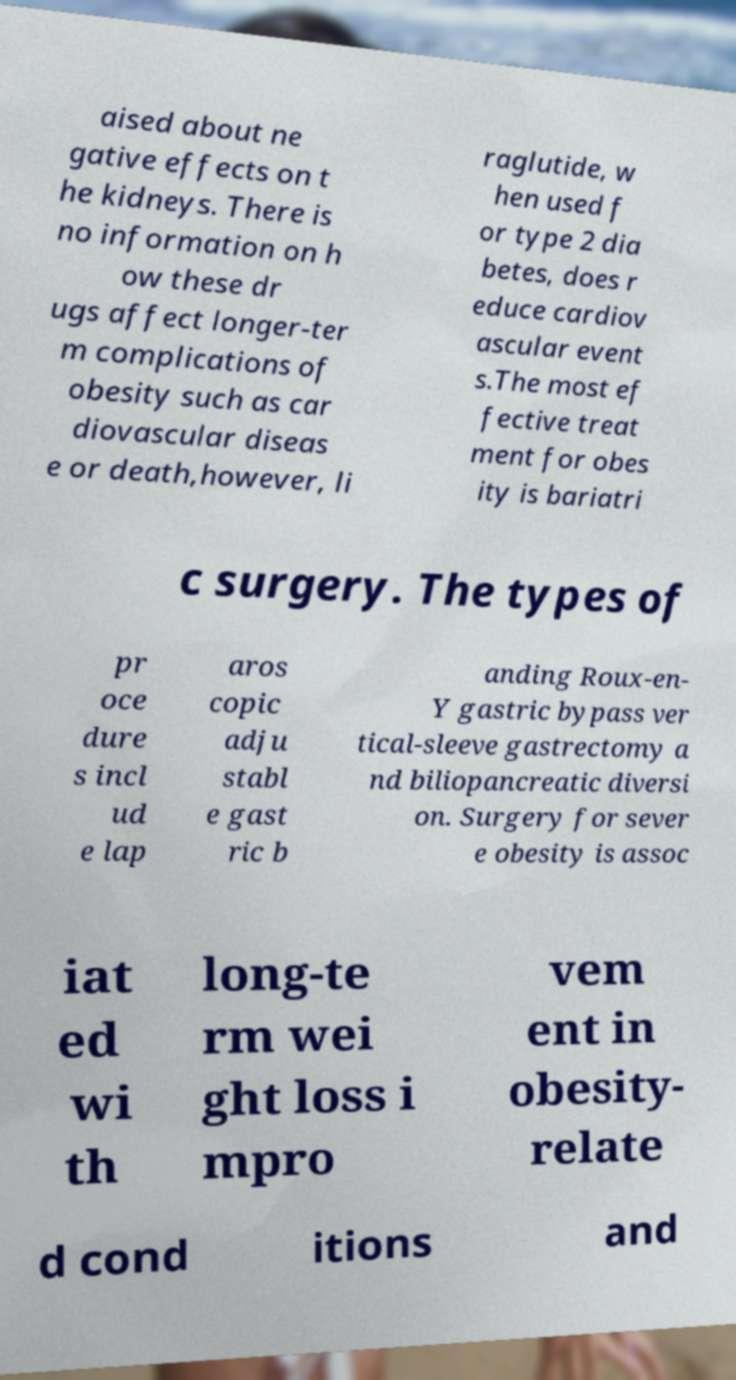Could you assist in decoding the text presented in this image and type it out clearly? aised about ne gative effects on t he kidneys. There is no information on h ow these dr ugs affect longer-ter m complications of obesity such as car diovascular diseas e or death,however, li raglutide, w hen used f or type 2 dia betes, does r educe cardiov ascular event s.The most ef fective treat ment for obes ity is bariatri c surgery. The types of pr oce dure s incl ud e lap aros copic adju stabl e gast ric b anding Roux-en- Y gastric bypass ver tical-sleeve gastrectomy a nd biliopancreatic diversi on. Surgery for sever e obesity is assoc iat ed wi th long-te rm wei ght loss i mpro vem ent in obesity- relate d cond itions and 